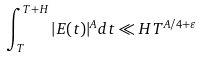Convert formula to latex. <formula><loc_0><loc_0><loc_500><loc_500>\int _ { T } ^ { T + H } | E ( t ) | ^ { A } d t \ll H T ^ { A / 4 + \varepsilon }</formula> 